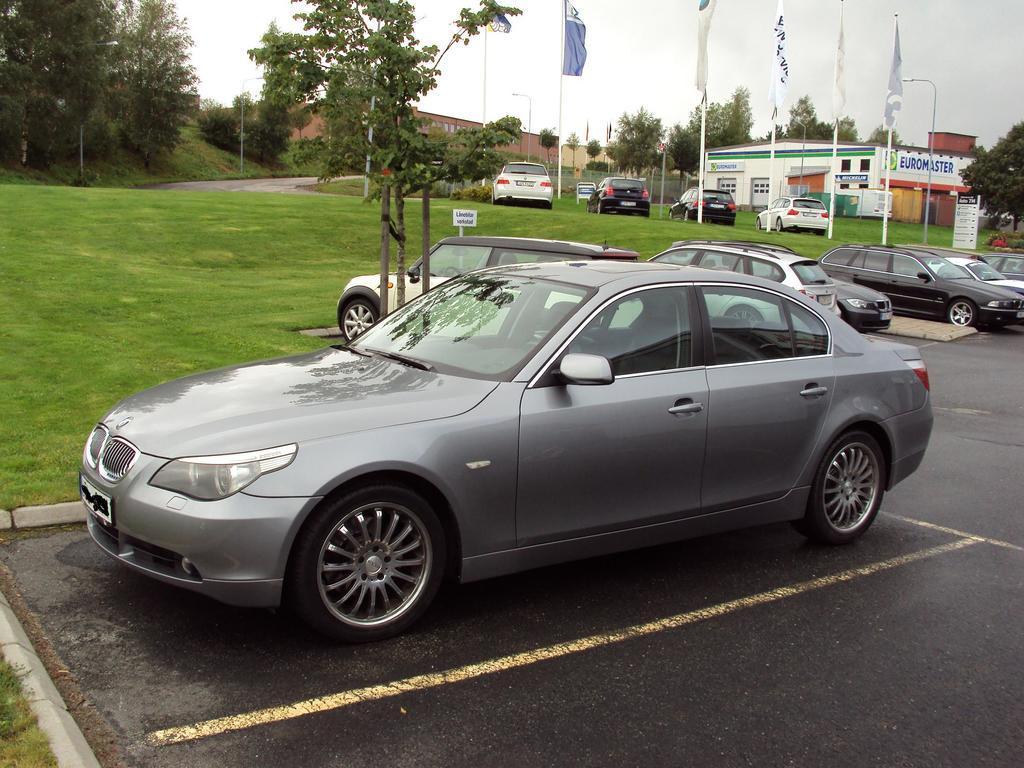In one or two sentences, can you explain what this image depicts? In this image, we can see vehicles and in the background, there are trees, flags, sheds, buildings and we can see boards and poles. At the bottom, there is road and ground and at the top, there is sky. 